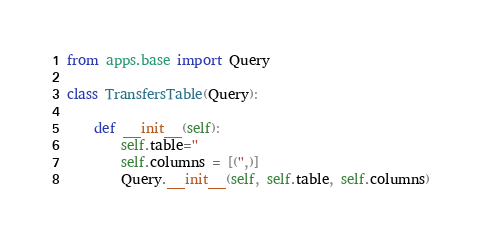Convert code to text. <code><loc_0><loc_0><loc_500><loc_500><_Python_>from apps.base import Query

class TransfersTable(Query):

    def __init__(self):
        self.table=''
        self.columns = [('',)]
        Query.__init__(self, self.table, self.columns)
</code> 